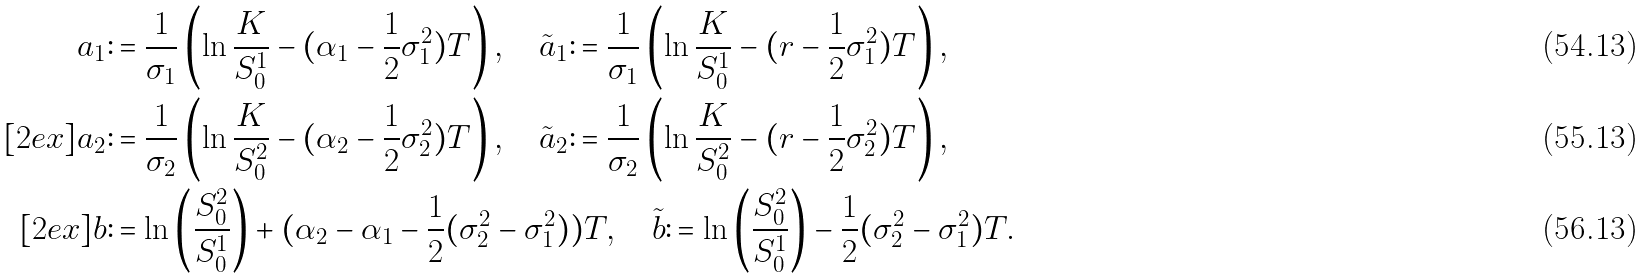Convert formula to latex. <formula><loc_0><loc_0><loc_500><loc_500>a _ { 1 } & \colon = \frac { 1 } { \sigma _ { 1 } } \left ( \ln \frac { K } { S ^ { 1 } _ { 0 } } - ( \alpha _ { 1 } - \frac { 1 } { 2 } \sigma _ { 1 } ^ { 2 } ) T \right ) , \quad \tilde { a } _ { 1 } \colon = \frac { 1 } { \sigma _ { 1 } } \left ( \ln \frac { K } { S ^ { 1 } _ { 0 } } - ( r - \frac { 1 } { 2 } \sigma _ { 1 } ^ { 2 } ) T \right ) , \\ [ 2 e x ] a _ { 2 } & \colon = \frac { 1 } { \sigma _ { 2 } } \left ( \ln \frac { K } { S ^ { 2 } _ { 0 } } - ( \alpha _ { 2 } - \frac { 1 } { 2 } \sigma _ { 2 } ^ { 2 } ) T \right ) , \quad \tilde { a } _ { 2 } \colon = \frac { 1 } { \sigma _ { 2 } } \left ( \ln \frac { K } { S ^ { 2 } _ { 0 } } - ( r - \frac { 1 } { 2 } \sigma _ { 2 } ^ { 2 } ) T \right ) , \\ [ 2 e x ] b & \colon = \ln \left ( \frac { S ^ { 2 } _ { 0 } } { S ^ { 1 } _ { 0 } } \right ) + ( \alpha _ { 2 } - \alpha _ { 1 } - \frac { 1 } { 2 } ( \sigma _ { 2 } ^ { 2 } - \sigma _ { 1 } ^ { 2 } ) ) T , \quad \tilde { b } \colon = \ln \left ( \frac { S ^ { 2 } _ { 0 } } { S ^ { 1 } _ { 0 } } \right ) - \frac { 1 } { 2 } ( \sigma _ { 2 } ^ { 2 } - \sigma _ { 1 } ^ { 2 } ) T .</formula> 